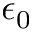<formula> <loc_0><loc_0><loc_500><loc_500>\epsilon _ { 0 }</formula> 